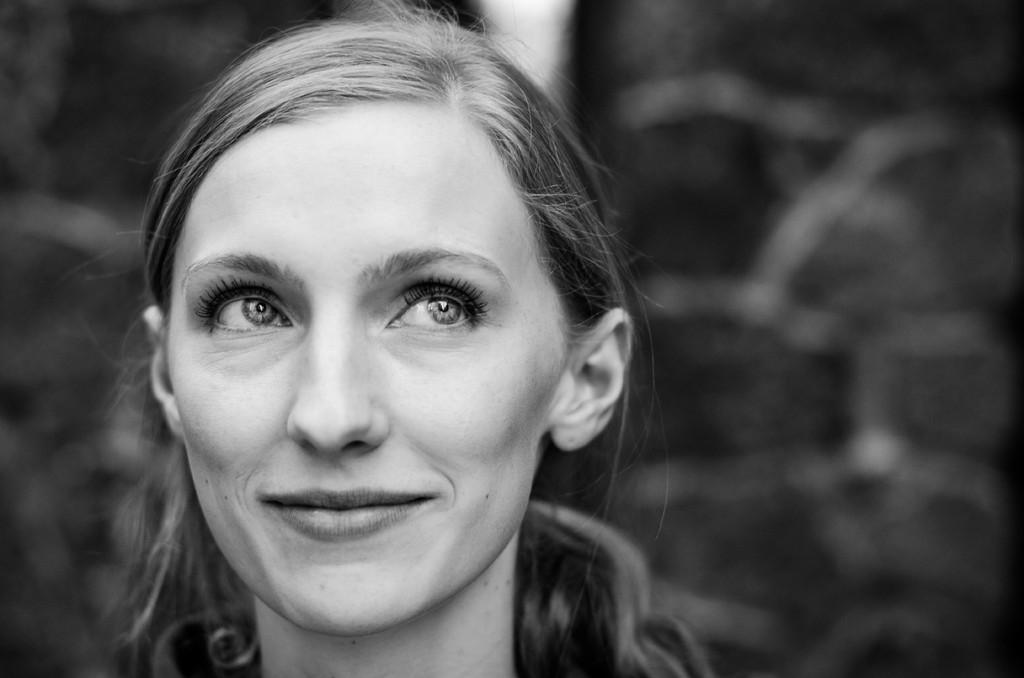What is the color scheme of the image? The image is black and white. Can you describe the main subject in the image? There is a lady in the image. What can be observed about the background of the image? The background of the image is blurred. How many brothers does the lady have in the image? There is no information about the lady's brothers in the image, as it only shows her and a blurred background. What type of kite is the lady holding in the image? There is no kite present in the image; it is black and white and features a lady and a blurred background. 